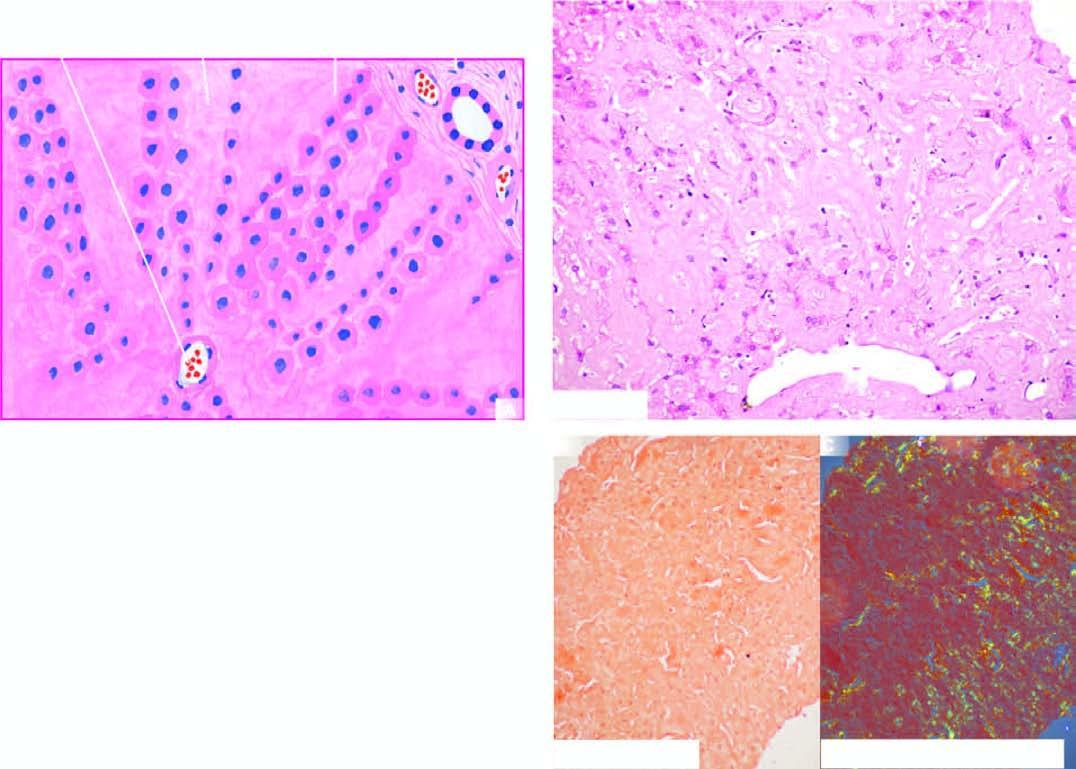what does congo red staining show?
Answer the question using a single word or phrase. Congophilia which under polarising microscopy 